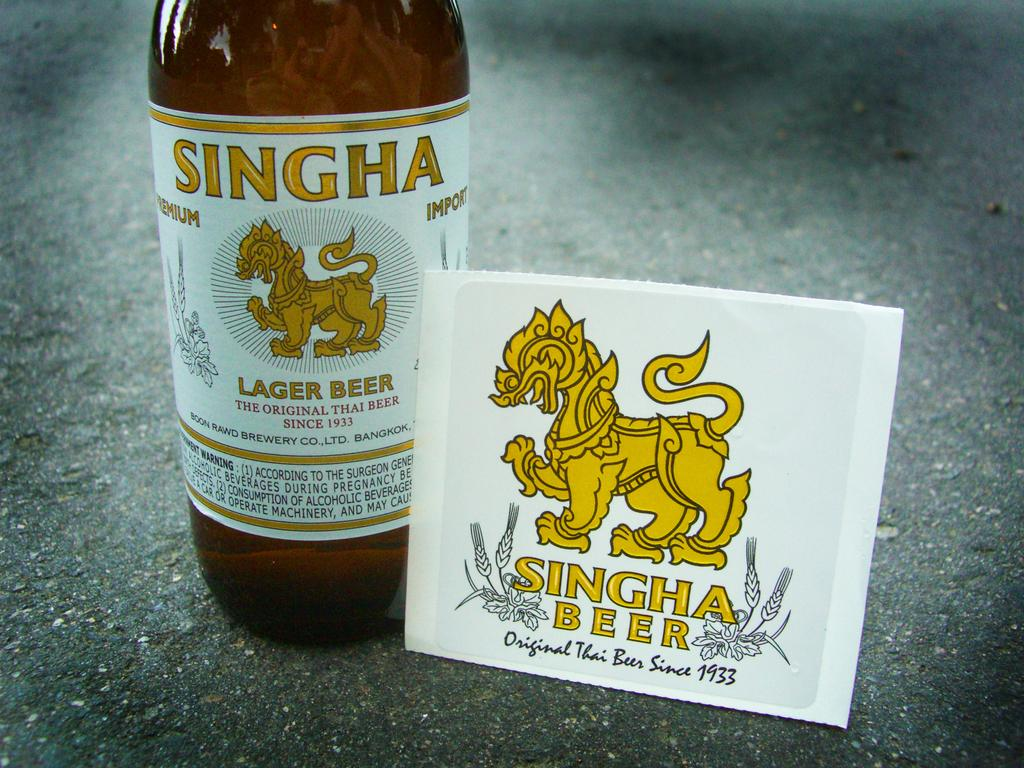<image>
Provide a brief description of the given image. a bottle of singha lager beer with a label in front of it 